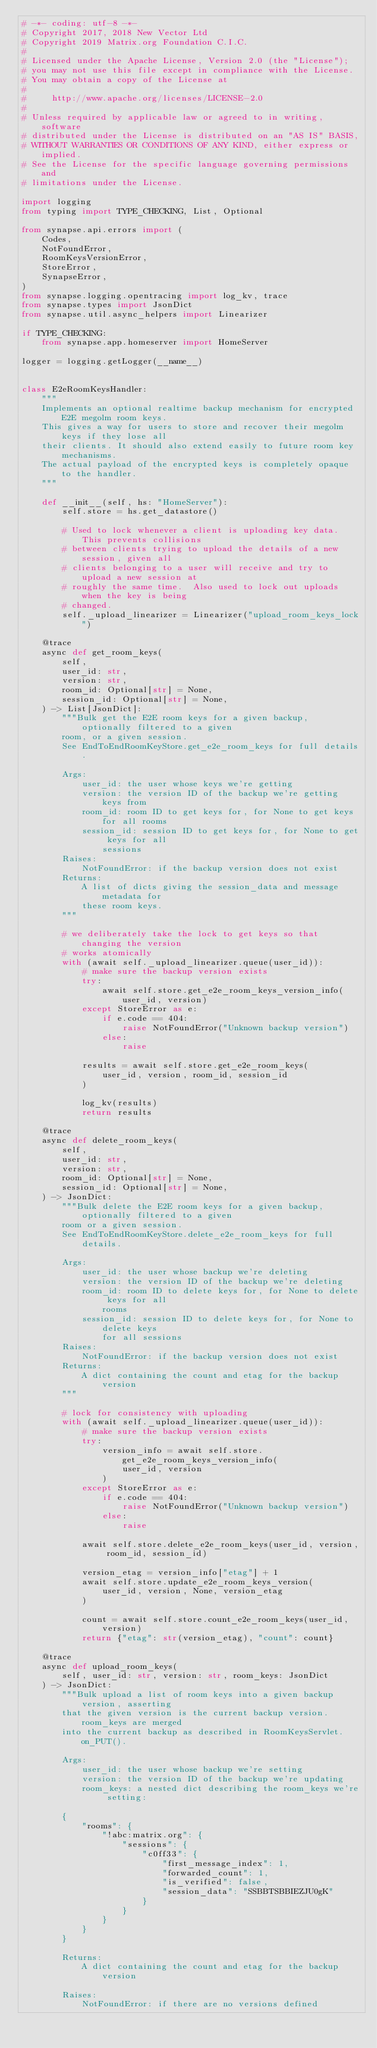<code> <loc_0><loc_0><loc_500><loc_500><_Python_># -*- coding: utf-8 -*-
# Copyright 2017, 2018 New Vector Ltd
# Copyright 2019 Matrix.org Foundation C.I.C.
#
# Licensed under the Apache License, Version 2.0 (the "License");
# you may not use this file except in compliance with the License.
# You may obtain a copy of the License at
#
#     http://www.apache.org/licenses/LICENSE-2.0
#
# Unless required by applicable law or agreed to in writing, software
# distributed under the License is distributed on an "AS IS" BASIS,
# WITHOUT WARRANTIES OR CONDITIONS OF ANY KIND, either express or implied.
# See the License for the specific language governing permissions and
# limitations under the License.

import logging
from typing import TYPE_CHECKING, List, Optional

from synapse.api.errors import (
    Codes,
    NotFoundError,
    RoomKeysVersionError,
    StoreError,
    SynapseError,
)
from synapse.logging.opentracing import log_kv, trace
from synapse.types import JsonDict
from synapse.util.async_helpers import Linearizer

if TYPE_CHECKING:
    from synapse.app.homeserver import HomeServer

logger = logging.getLogger(__name__)


class E2eRoomKeysHandler:
    """
    Implements an optional realtime backup mechanism for encrypted E2E megolm room keys.
    This gives a way for users to store and recover their megolm keys if they lose all
    their clients. It should also extend easily to future room key mechanisms.
    The actual payload of the encrypted keys is completely opaque to the handler.
    """

    def __init__(self, hs: "HomeServer"):
        self.store = hs.get_datastore()

        # Used to lock whenever a client is uploading key data.  This prevents collisions
        # between clients trying to upload the details of a new session, given all
        # clients belonging to a user will receive and try to upload a new session at
        # roughly the same time.  Also used to lock out uploads when the key is being
        # changed.
        self._upload_linearizer = Linearizer("upload_room_keys_lock")

    @trace
    async def get_room_keys(
        self,
        user_id: str,
        version: str,
        room_id: Optional[str] = None,
        session_id: Optional[str] = None,
    ) -> List[JsonDict]:
        """Bulk get the E2E room keys for a given backup, optionally filtered to a given
        room, or a given session.
        See EndToEndRoomKeyStore.get_e2e_room_keys for full details.

        Args:
            user_id: the user whose keys we're getting
            version: the version ID of the backup we're getting keys from
            room_id: room ID to get keys for, for None to get keys for all rooms
            session_id: session ID to get keys for, for None to get keys for all
                sessions
        Raises:
            NotFoundError: if the backup version does not exist
        Returns:
            A list of dicts giving the session_data and message metadata for
            these room keys.
        """

        # we deliberately take the lock to get keys so that changing the version
        # works atomically
        with (await self._upload_linearizer.queue(user_id)):
            # make sure the backup version exists
            try:
                await self.store.get_e2e_room_keys_version_info(user_id, version)
            except StoreError as e:
                if e.code == 404:
                    raise NotFoundError("Unknown backup version")
                else:
                    raise

            results = await self.store.get_e2e_room_keys(
                user_id, version, room_id, session_id
            )

            log_kv(results)
            return results

    @trace
    async def delete_room_keys(
        self,
        user_id: str,
        version: str,
        room_id: Optional[str] = None,
        session_id: Optional[str] = None,
    ) -> JsonDict:
        """Bulk delete the E2E room keys for a given backup, optionally filtered to a given
        room or a given session.
        See EndToEndRoomKeyStore.delete_e2e_room_keys for full details.

        Args:
            user_id: the user whose backup we're deleting
            version: the version ID of the backup we're deleting
            room_id: room ID to delete keys for, for None to delete keys for all
                rooms
            session_id: session ID to delete keys for, for None to delete keys
                for all sessions
        Raises:
            NotFoundError: if the backup version does not exist
        Returns:
            A dict containing the count and etag for the backup version
        """

        # lock for consistency with uploading
        with (await self._upload_linearizer.queue(user_id)):
            # make sure the backup version exists
            try:
                version_info = await self.store.get_e2e_room_keys_version_info(
                    user_id, version
                )
            except StoreError as e:
                if e.code == 404:
                    raise NotFoundError("Unknown backup version")
                else:
                    raise

            await self.store.delete_e2e_room_keys(user_id, version, room_id, session_id)

            version_etag = version_info["etag"] + 1
            await self.store.update_e2e_room_keys_version(
                user_id, version, None, version_etag
            )

            count = await self.store.count_e2e_room_keys(user_id, version)
            return {"etag": str(version_etag), "count": count}

    @trace
    async def upload_room_keys(
        self, user_id: str, version: str, room_keys: JsonDict
    ) -> JsonDict:
        """Bulk upload a list of room keys into a given backup version, asserting
        that the given version is the current backup version.  room_keys are merged
        into the current backup as described in RoomKeysServlet.on_PUT().

        Args:
            user_id: the user whose backup we're setting
            version: the version ID of the backup we're updating
            room_keys: a nested dict describing the room_keys we're setting:

        {
            "rooms": {
                "!abc:matrix.org": {
                    "sessions": {
                        "c0ff33": {
                            "first_message_index": 1,
                            "forwarded_count": 1,
                            "is_verified": false,
                            "session_data": "SSBBTSBBIEZJU0gK"
                        }
                    }
                }
            }
        }

        Returns:
            A dict containing the count and etag for the backup version

        Raises:
            NotFoundError: if there are no versions defined</code> 